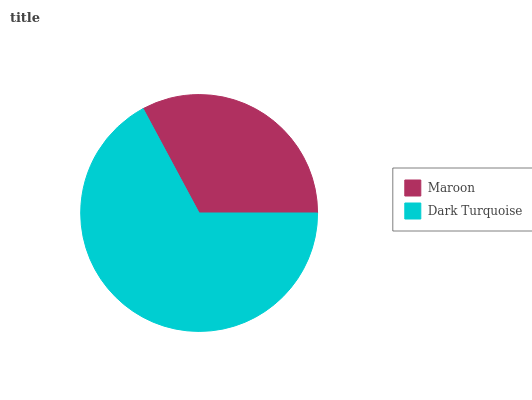Is Maroon the minimum?
Answer yes or no. Yes. Is Dark Turquoise the maximum?
Answer yes or no. Yes. Is Dark Turquoise the minimum?
Answer yes or no. No. Is Dark Turquoise greater than Maroon?
Answer yes or no. Yes. Is Maroon less than Dark Turquoise?
Answer yes or no. Yes. Is Maroon greater than Dark Turquoise?
Answer yes or no. No. Is Dark Turquoise less than Maroon?
Answer yes or no. No. Is Dark Turquoise the high median?
Answer yes or no. Yes. Is Maroon the low median?
Answer yes or no. Yes. Is Maroon the high median?
Answer yes or no. No. Is Dark Turquoise the low median?
Answer yes or no. No. 